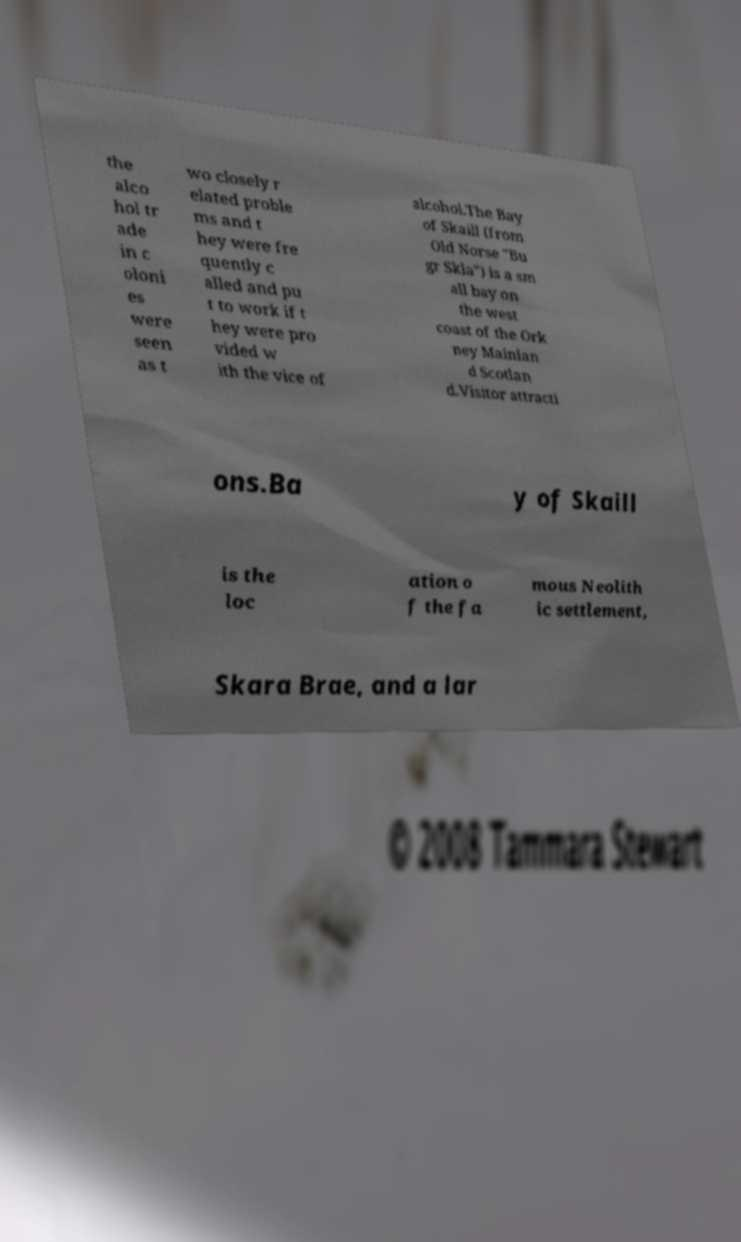Please read and relay the text visible in this image. What does it say? the alco hol tr ade in c oloni es were seen as t wo closely r elated proble ms and t hey were fre quently c alled and pu t to work if t hey were pro vided w ith the vice of alcohol.The Bay of Skaill (from Old Norse "Bu gr Skla") is a sm all bay on the west coast of the Ork ney Mainlan d Scotlan d.Visitor attracti ons.Ba y of Skaill is the loc ation o f the fa mous Neolith ic settlement, Skara Brae, and a lar 